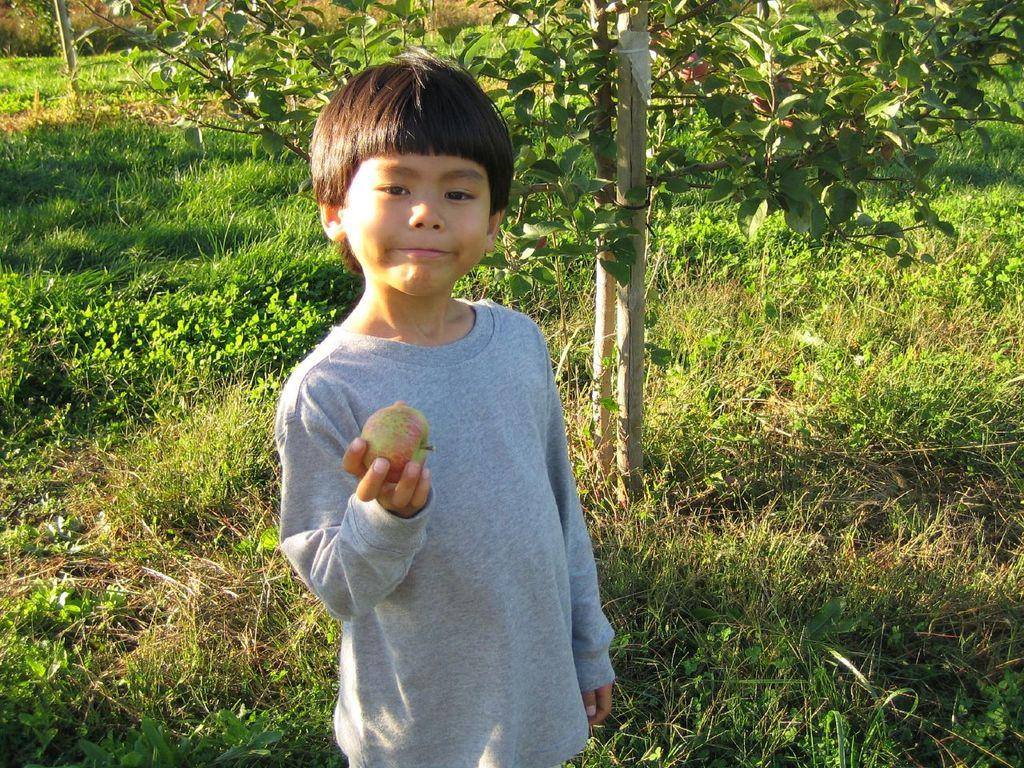Who is the main subject in the image? There is a child in the image. What is the child holding in the image? The child is holding an apple. What type of surface is visible in the image? There is grass visible in the image. What other natural elements can be seen in the image? There are plants in the image. Are there any man-made structures visible in the image? Yes, there are wooden poles in the image. What type of wheel can be seen in the image? There is no wheel present in the image. 